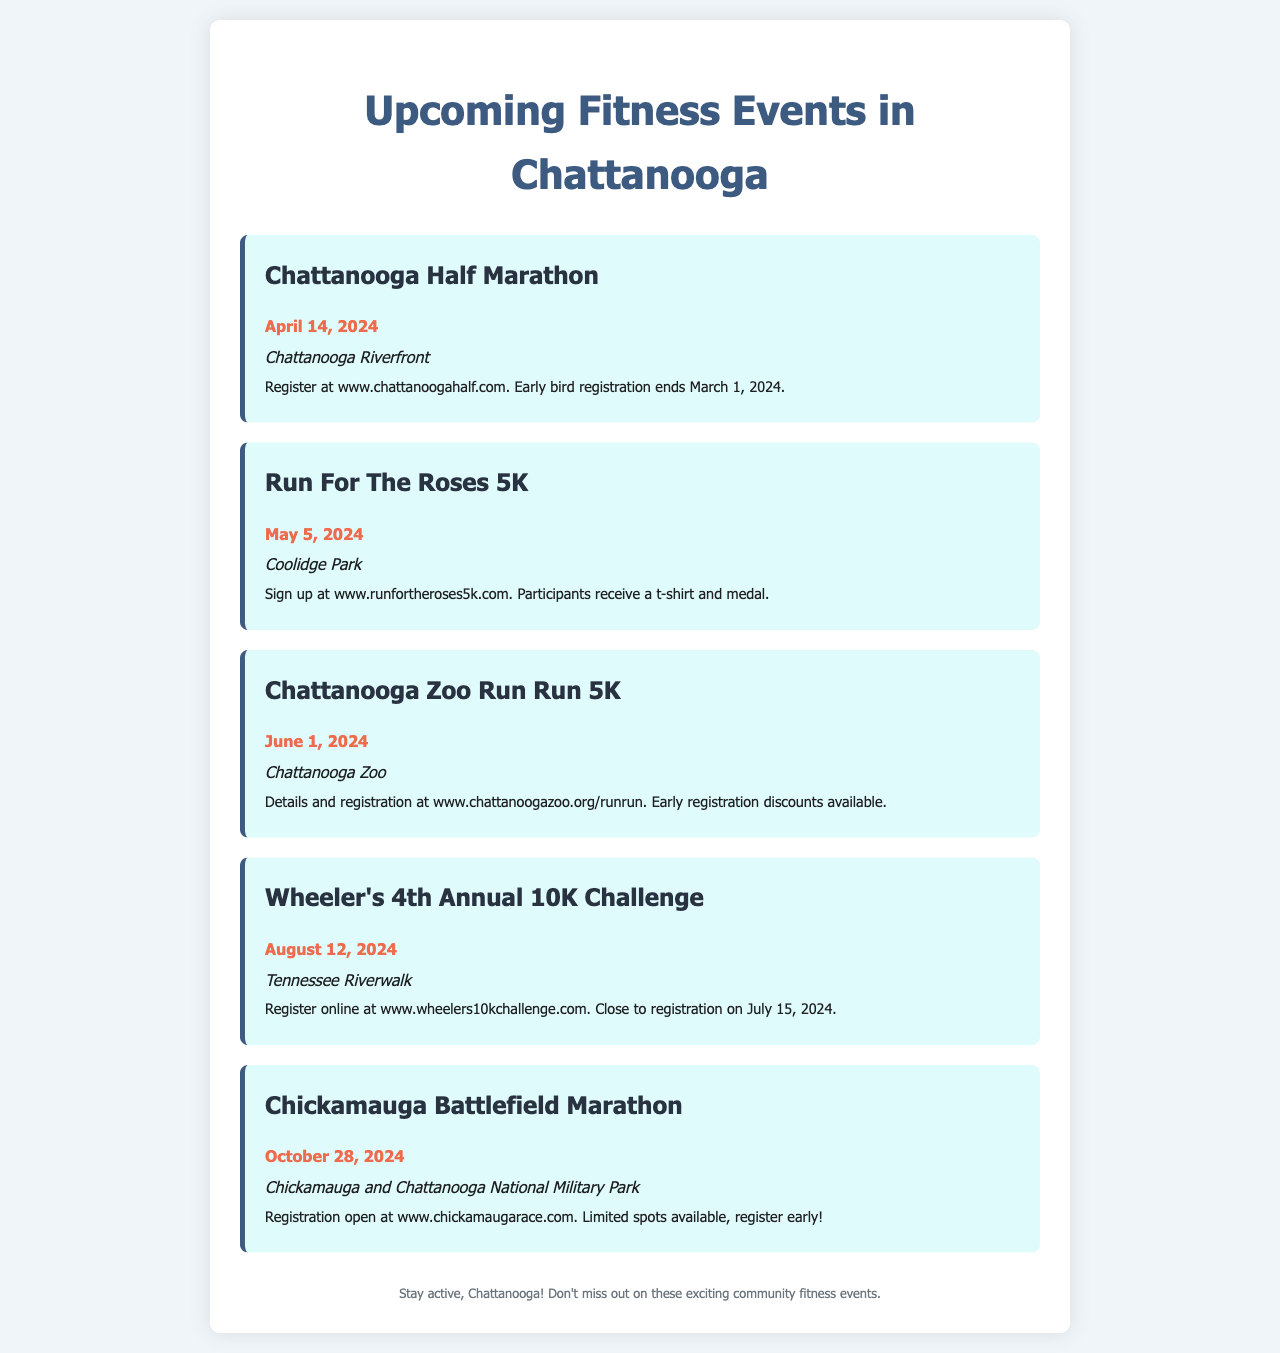What is the date for the Chattanooga Half Marathon? The date is specifically mentioned in the document as April 14, 2024.
Answer: April 14, 2024 Where is the Run For The Roses 5K located? The document states that this event will take place at Coolidge Park.
Answer: Coolidge Park What is the title of the event on June 1, 2024? This event is referred to as the Chattanooga Zoo Run Run 5K.
Answer: Chattanooga Zoo Run Run 5K What is the early bird registration deadline for the Half Marathon? The document indicates that early bird registration ends on March 1, 2024.
Answer: March 1, 2024 Which event takes place at the Chickamauga and Chattanooga National Military Park? This event is titled Chickamauga Battlefield Marathon.
Answer: Chickamauga Battlefield Marathon What type of event is the Wheeler's 4th Annual 10K Challenge? The document identifies it as a 10K running challenge.
Answer: 10K Challenge How can participants of the Run For The Roses 5K register? Registration details can be found at the provided website www.runfortheroses5k.com.
Answer: www.runfortheroses5k.com What benefits are mentioned for participants of the Run For The Roses 5K? Participants are stated to receive a t-shirt and medal according to the document.
Answer: t-shirt and medal 